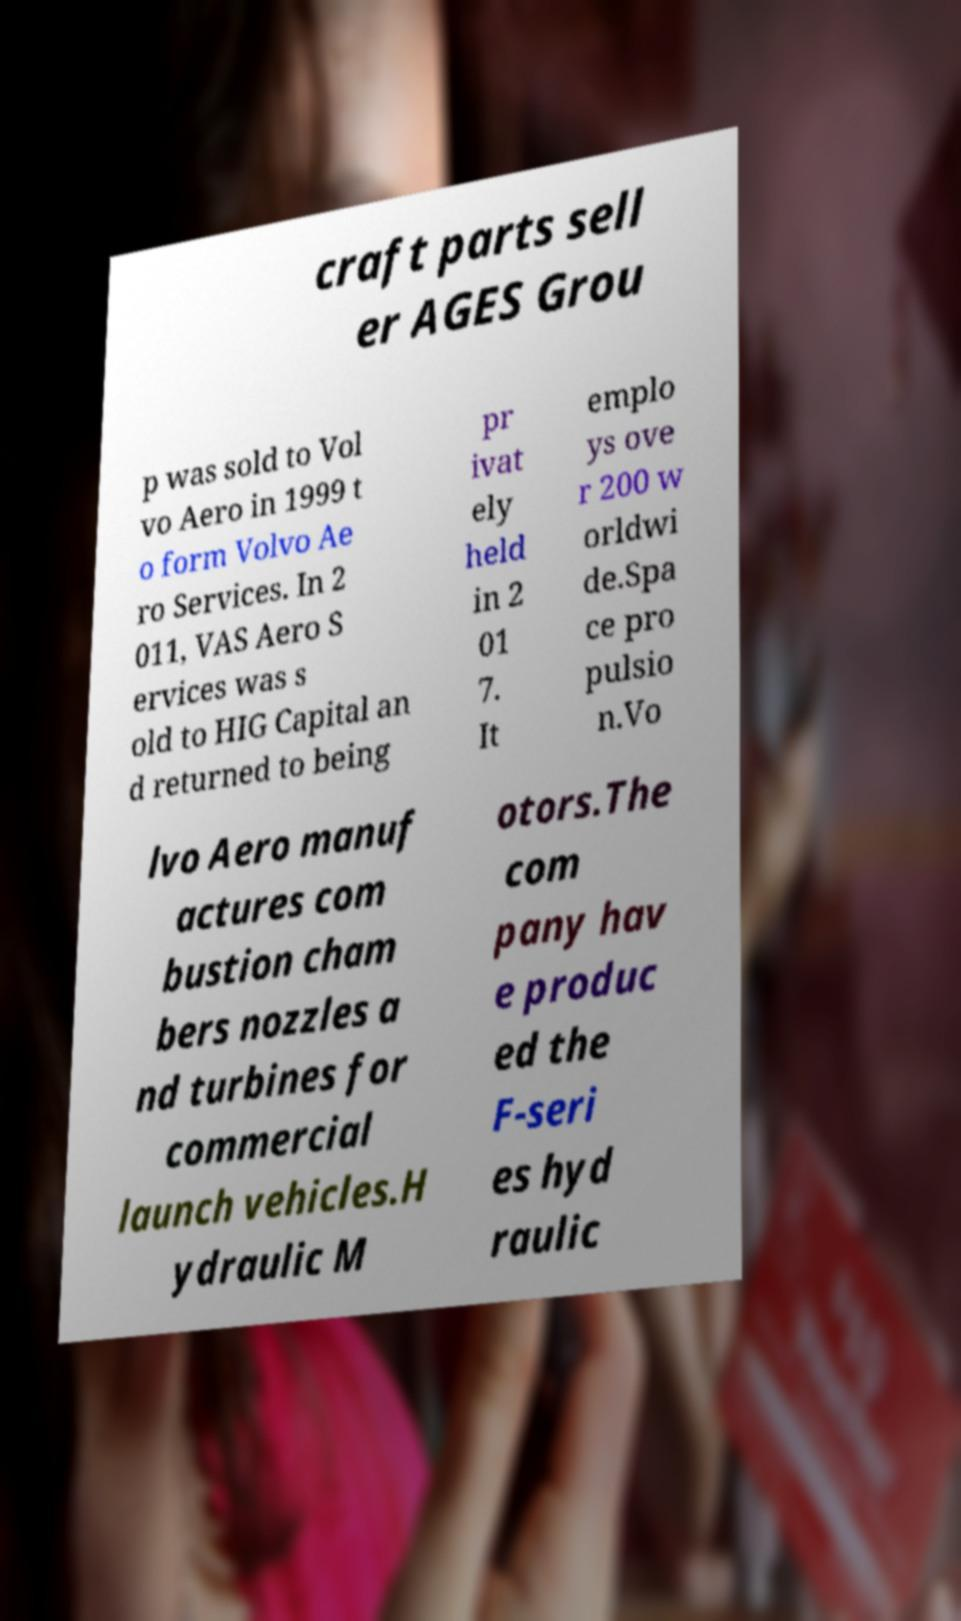Could you extract and type out the text from this image? craft parts sell er AGES Grou p was sold to Vol vo Aero in 1999 t o form Volvo Ae ro Services. In 2 011, VAS Aero S ervices was s old to HIG Capital an d returned to being pr ivat ely held in 2 01 7. It emplo ys ove r 200 w orldwi de.Spa ce pro pulsio n.Vo lvo Aero manuf actures com bustion cham bers nozzles a nd turbines for commercial launch vehicles.H ydraulic M otors.The com pany hav e produc ed the F-seri es hyd raulic 